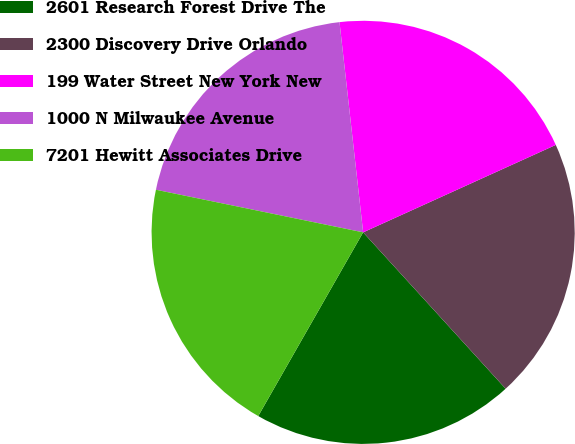Convert chart. <chart><loc_0><loc_0><loc_500><loc_500><pie_chart><fcel>2601 Research Forest Drive The<fcel>2300 Discovery Drive Orlando<fcel>199 Water Street New York New<fcel>1000 N Milwaukee Avenue<fcel>7201 Hewitt Associates Drive<nl><fcel>20.02%<fcel>20.02%<fcel>20.0%<fcel>19.99%<fcel>19.97%<nl></chart> 